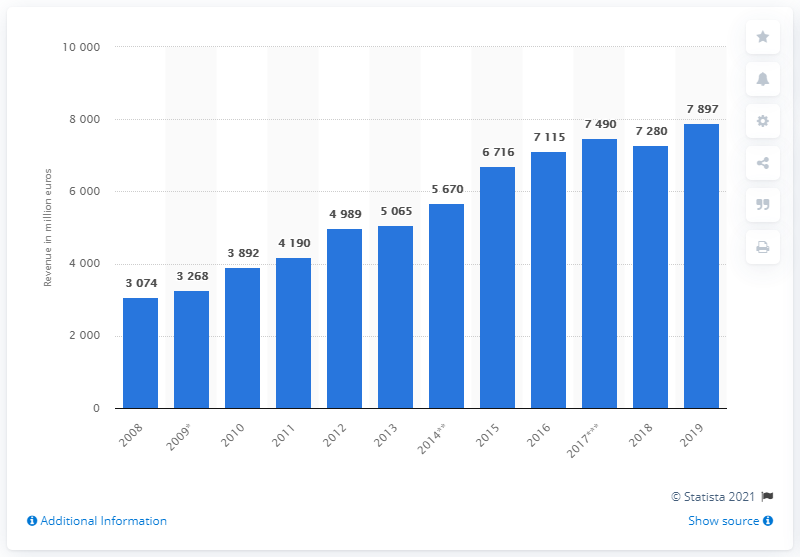Indicate a few pertinent items in this graphic. Essilor's global revenue in 2019 was 7,897. 